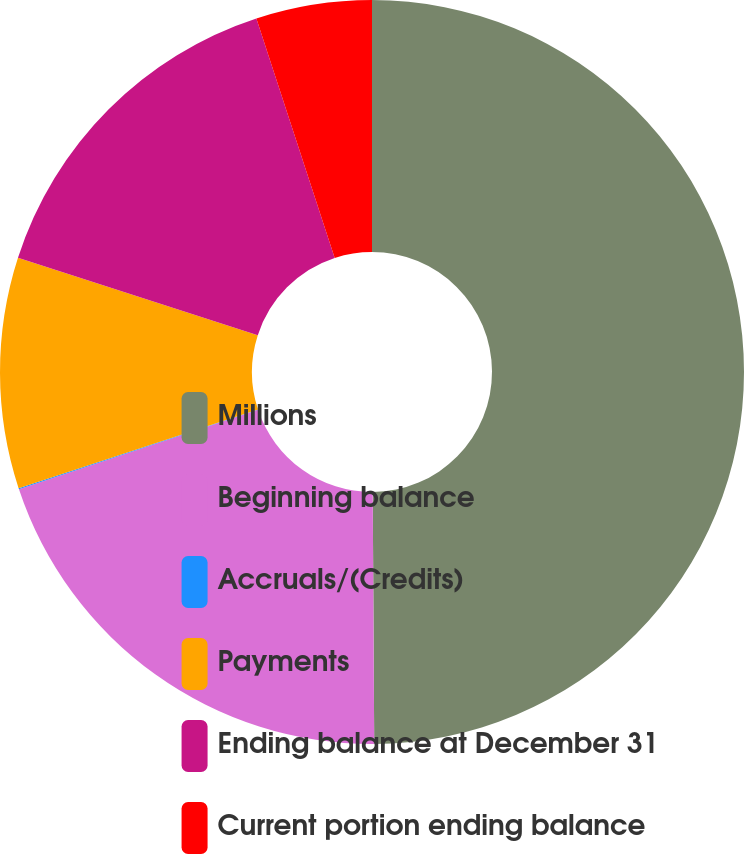Convert chart to OTSL. <chart><loc_0><loc_0><loc_500><loc_500><pie_chart><fcel>Millions<fcel>Beginning balance<fcel>Accruals/(Credits)<fcel>Payments<fcel>Ending balance at December 31<fcel>Current portion ending balance<nl><fcel>49.9%<fcel>19.99%<fcel>0.05%<fcel>10.02%<fcel>15.0%<fcel>5.03%<nl></chart> 